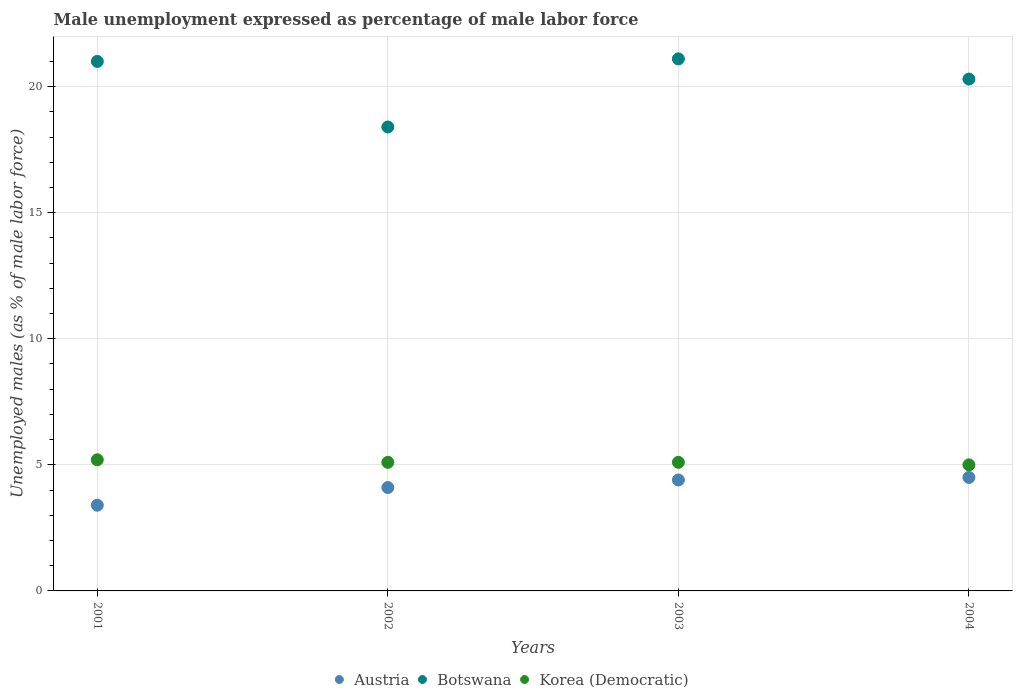What is the unemployment in males in in Korea (Democratic) in 2003?
Provide a succinct answer. 5.1. Across all years, what is the maximum unemployment in males in in Korea (Democratic)?
Ensure brevity in your answer.  5.2. Across all years, what is the minimum unemployment in males in in Botswana?
Offer a terse response. 18.4. In which year was the unemployment in males in in Austria maximum?
Provide a short and direct response. 2004. In which year was the unemployment in males in in Korea (Democratic) minimum?
Offer a terse response. 2004. What is the total unemployment in males in in Korea (Democratic) in the graph?
Provide a succinct answer. 20.4. What is the difference between the unemployment in males in in Korea (Democratic) in 2001 and that in 2002?
Your response must be concise. 0.1. What is the difference between the unemployment in males in in Austria in 2004 and the unemployment in males in in Botswana in 2002?
Provide a succinct answer. -13.9. What is the average unemployment in males in in Korea (Democratic) per year?
Your answer should be compact. 5.1. In the year 2001, what is the difference between the unemployment in males in in Austria and unemployment in males in in Korea (Democratic)?
Provide a succinct answer. -1.8. What is the ratio of the unemployment in males in in Austria in 2001 to that in 2003?
Provide a succinct answer. 0.77. Is the unemployment in males in in Korea (Democratic) in 2003 less than that in 2004?
Keep it short and to the point. No. What is the difference between the highest and the second highest unemployment in males in in Korea (Democratic)?
Your answer should be very brief. 0.1. What is the difference between the highest and the lowest unemployment in males in in Austria?
Provide a short and direct response. 1.1. In how many years, is the unemployment in males in in Korea (Democratic) greater than the average unemployment in males in in Korea (Democratic) taken over all years?
Make the answer very short. 1. Is the sum of the unemployment in males in in Austria in 2001 and 2002 greater than the maximum unemployment in males in in Korea (Democratic) across all years?
Make the answer very short. Yes. Is it the case that in every year, the sum of the unemployment in males in in Korea (Democratic) and unemployment in males in in Botswana  is greater than the unemployment in males in in Austria?
Give a very brief answer. Yes. Is the unemployment in males in in Austria strictly greater than the unemployment in males in in Korea (Democratic) over the years?
Your response must be concise. No. What is the difference between two consecutive major ticks on the Y-axis?
Your answer should be compact. 5. Does the graph contain any zero values?
Provide a succinct answer. No. Does the graph contain grids?
Provide a succinct answer. Yes. What is the title of the graph?
Provide a succinct answer. Male unemployment expressed as percentage of male labor force. Does "Burundi" appear as one of the legend labels in the graph?
Offer a terse response. No. What is the label or title of the X-axis?
Offer a terse response. Years. What is the label or title of the Y-axis?
Provide a short and direct response. Unemployed males (as % of male labor force). What is the Unemployed males (as % of male labor force) in Austria in 2001?
Your answer should be very brief. 3.4. What is the Unemployed males (as % of male labor force) in Botswana in 2001?
Your answer should be compact. 21. What is the Unemployed males (as % of male labor force) in Korea (Democratic) in 2001?
Provide a succinct answer. 5.2. What is the Unemployed males (as % of male labor force) of Austria in 2002?
Provide a succinct answer. 4.1. What is the Unemployed males (as % of male labor force) in Botswana in 2002?
Give a very brief answer. 18.4. What is the Unemployed males (as % of male labor force) in Korea (Democratic) in 2002?
Make the answer very short. 5.1. What is the Unemployed males (as % of male labor force) in Austria in 2003?
Give a very brief answer. 4.4. What is the Unemployed males (as % of male labor force) of Botswana in 2003?
Offer a terse response. 21.1. What is the Unemployed males (as % of male labor force) of Korea (Democratic) in 2003?
Keep it short and to the point. 5.1. What is the Unemployed males (as % of male labor force) in Austria in 2004?
Your answer should be compact. 4.5. What is the Unemployed males (as % of male labor force) of Botswana in 2004?
Give a very brief answer. 20.3. What is the Unemployed males (as % of male labor force) in Korea (Democratic) in 2004?
Offer a very short reply. 5. Across all years, what is the maximum Unemployed males (as % of male labor force) in Austria?
Keep it short and to the point. 4.5. Across all years, what is the maximum Unemployed males (as % of male labor force) of Botswana?
Your answer should be very brief. 21.1. Across all years, what is the maximum Unemployed males (as % of male labor force) in Korea (Democratic)?
Ensure brevity in your answer.  5.2. Across all years, what is the minimum Unemployed males (as % of male labor force) in Austria?
Provide a short and direct response. 3.4. Across all years, what is the minimum Unemployed males (as % of male labor force) in Botswana?
Your response must be concise. 18.4. What is the total Unemployed males (as % of male labor force) of Botswana in the graph?
Ensure brevity in your answer.  80.8. What is the total Unemployed males (as % of male labor force) in Korea (Democratic) in the graph?
Offer a terse response. 20.4. What is the difference between the Unemployed males (as % of male labor force) of Korea (Democratic) in 2001 and that in 2002?
Your answer should be compact. 0.1. What is the difference between the Unemployed males (as % of male labor force) of Austria in 2001 and that in 2003?
Offer a terse response. -1. What is the difference between the Unemployed males (as % of male labor force) of Botswana in 2001 and that in 2004?
Your answer should be very brief. 0.7. What is the difference between the Unemployed males (as % of male labor force) of Austria in 2002 and that in 2003?
Your answer should be compact. -0.3. What is the difference between the Unemployed males (as % of male labor force) in Botswana in 2002 and that in 2003?
Offer a terse response. -2.7. What is the difference between the Unemployed males (as % of male labor force) in Korea (Democratic) in 2002 and that in 2003?
Provide a succinct answer. 0. What is the difference between the Unemployed males (as % of male labor force) in Austria in 2002 and that in 2004?
Your response must be concise. -0.4. What is the difference between the Unemployed males (as % of male labor force) in Botswana in 2002 and that in 2004?
Keep it short and to the point. -1.9. What is the difference between the Unemployed males (as % of male labor force) of Korea (Democratic) in 2002 and that in 2004?
Offer a terse response. 0.1. What is the difference between the Unemployed males (as % of male labor force) in Botswana in 2003 and that in 2004?
Provide a short and direct response. 0.8. What is the difference between the Unemployed males (as % of male labor force) in Austria in 2001 and the Unemployed males (as % of male labor force) in Korea (Democratic) in 2002?
Offer a very short reply. -1.7. What is the difference between the Unemployed males (as % of male labor force) in Botswana in 2001 and the Unemployed males (as % of male labor force) in Korea (Democratic) in 2002?
Your response must be concise. 15.9. What is the difference between the Unemployed males (as % of male labor force) in Austria in 2001 and the Unemployed males (as % of male labor force) in Botswana in 2003?
Provide a short and direct response. -17.7. What is the difference between the Unemployed males (as % of male labor force) of Austria in 2001 and the Unemployed males (as % of male labor force) of Botswana in 2004?
Provide a short and direct response. -16.9. What is the difference between the Unemployed males (as % of male labor force) of Austria in 2002 and the Unemployed males (as % of male labor force) of Botswana in 2003?
Keep it short and to the point. -17. What is the difference between the Unemployed males (as % of male labor force) in Austria in 2002 and the Unemployed males (as % of male labor force) in Korea (Democratic) in 2003?
Your answer should be very brief. -1. What is the difference between the Unemployed males (as % of male labor force) in Botswana in 2002 and the Unemployed males (as % of male labor force) in Korea (Democratic) in 2003?
Your answer should be compact. 13.3. What is the difference between the Unemployed males (as % of male labor force) in Austria in 2002 and the Unemployed males (as % of male labor force) in Botswana in 2004?
Your response must be concise. -16.2. What is the difference between the Unemployed males (as % of male labor force) of Austria in 2002 and the Unemployed males (as % of male labor force) of Korea (Democratic) in 2004?
Offer a very short reply. -0.9. What is the difference between the Unemployed males (as % of male labor force) in Austria in 2003 and the Unemployed males (as % of male labor force) in Botswana in 2004?
Provide a short and direct response. -15.9. What is the average Unemployed males (as % of male labor force) in Botswana per year?
Your answer should be compact. 20.2. What is the average Unemployed males (as % of male labor force) in Korea (Democratic) per year?
Offer a terse response. 5.1. In the year 2001, what is the difference between the Unemployed males (as % of male labor force) in Austria and Unemployed males (as % of male labor force) in Botswana?
Your answer should be compact. -17.6. In the year 2001, what is the difference between the Unemployed males (as % of male labor force) of Austria and Unemployed males (as % of male labor force) of Korea (Democratic)?
Keep it short and to the point. -1.8. In the year 2002, what is the difference between the Unemployed males (as % of male labor force) of Austria and Unemployed males (as % of male labor force) of Botswana?
Your answer should be very brief. -14.3. In the year 2002, what is the difference between the Unemployed males (as % of male labor force) in Austria and Unemployed males (as % of male labor force) in Korea (Democratic)?
Provide a short and direct response. -1. In the year 2002, what is the difference between the Unemployed males (as % of male labor force) of Botswana and Unemployed males (as % of male labor force) of Korea (Democratic)?
Keep it short and to the point. 13.3. In the year 2003, what is the difference between the Unemployed males (as % of male labor force) of Austria and Unemployed males (as % of male labor force) of Botswana?
Provide a succinct answer. -16.7. In the year 2003, what is the difference between the Unemployed males (as % of male labor force) in Botswana and Unemployed males (as % of male labor force) in Korea (Democratic)?
Keep it short and to the point. 16. In the year 2004, what is the difference between the Unemployed males (as % of male labor force) in Austria and Unemployed males (as % of male labor force) in Botswana?
Keep it short and to the point. -15.8. In the year 2004, what is the difference between the Unemployed males (as % of male labor force) in Austria and Unemployed males (as % of male labor force) in Korea (Democratic)?
Provide a short and direct response. -0.5. What is the ratio of the Unemployed males (as % of male labor force) in Austria in 2001 to that in 2002?
Offer a very short reply. 0.83. What is the ratio of the Unemployed males (as % of male labor force) in Botswana in 2001 to that in 2002?
Your answer should be very brief. 1.14. What is the ratio of the Unemployed males (as % of male labor force) of Korea (Democratic) in 2001 to that in 2002?
Ensure brevity in your answer.  1.02. What is the ratio of the Unemployed males (as % of male labor force) in Austria in 2001 to that in 2003?
Make the answer very short. 0.77. What is the ratio of the Unemployed males (as % of male labor force) in Korea (Democratic) in 2001 to that in 2003?
Offer a very short reply. 1.02. What is the ratio of the Unemployed males (as % of male labor force) of Austria in 2001 to that in 2004?
Your answer should be compact. 0.76. What is the ratio of the Unemployed males (as % of male labor force) in Botswana in 2001 to that in 2004?
Your answer should be very brief. 1.03. What is the ratio of the Unemployed males (as % of male labor force) of Austria in 2002 to that in 2003?
Give a very brief answer. 0.93. What is the ratio of the Unemployed males (as % of male labor force) in Botswana in 2002 to that in 2003?
Your answer should be compact. 0.87. What is the ratio of the Unemployed males (as % of male labor force) of Korea (Democratic) in 2002 to that in 2003?
Ensure brevity in your answer.  1. What is the ratio of the Unemployed males (as % of male labor force) of Austria in 2002 to that in 2004?
Ensure brevity in your answer.  0.91. What is the ratio of the Unemployed males (as % of male labor force) in Botswana in 2002 to that in 2004?
Give a very brief answer. 0.91. What is the ratio of the Unemployed males (as % of male labor force) of Austria in 2003 to that in 2004?
Your answer should be compact. 0.98. What is the ratio of the Unemployed males (as % of male labor force) of Botswana in 2003 to that in 2004?
Make the answer very short. 1.04. What is the difference between the highest and the lowest Unemployed males (as % of male labor force) of Botswana?
Ensure brevity in your answer.  2.7. 